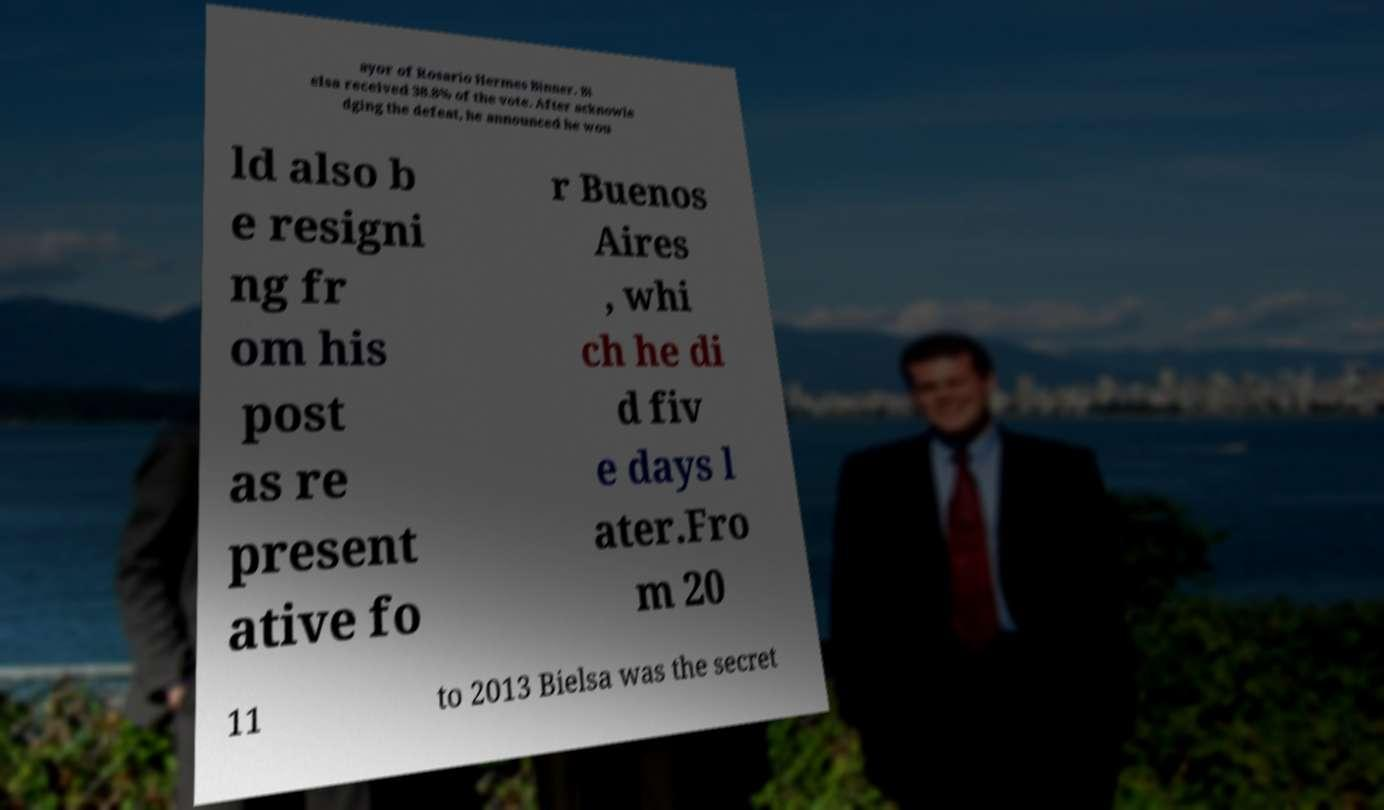Could you extract and type out the text from this image? ayor of Rosario Hermes Binner. Bi elsa received 38.8% of the vote. After acknowle dging the defeat, he announced he wou ld also b e resigni ng fr om his post as re present ative fo r Buenos Aires , whi ch he di d fiv e days l ater.Fro m 20 11 to 2013 Bielsa was the secret 